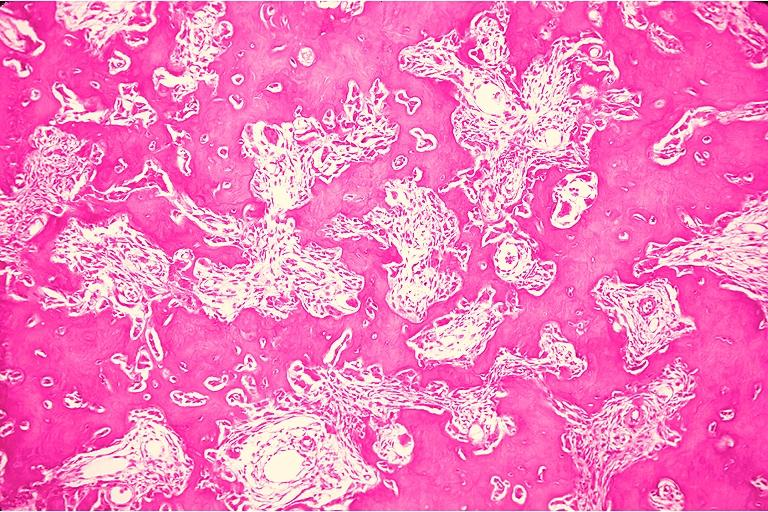what does this image show?
Answer the question using a single word or phrase. Osteoblastoma 